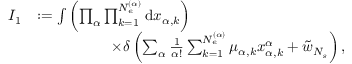<formula> <loc_0><loc_0><loc_500><loc_500>\begin{array} { r l } { I _ { 1 } } & { \colon = \int { \left ( \prod _ { \alpha } \prod _ { k = 1 } ^ { N _ { e } ^ { ( \alpha ) } } { d x _ { \alpha , k } } \right ) } } \\ & { \quad \times \delta \left ( \sum _ { \alpha } \frac { 1 } { \alpha ! } \sum _ { k = 1 } ^ { N _ { e } ^ { ( \alpha ) } } { \mu _ { \alpha , k } x _ { \alpha , k } ^ { \alpha } } + \tilde { w } _ { N _ { s } } \right ) , } \end{array}</formula> 